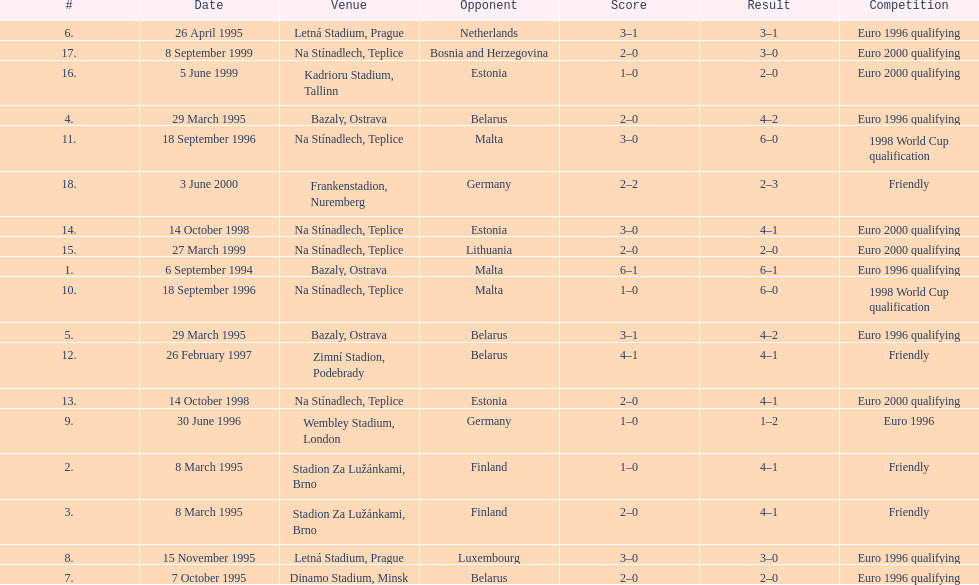How many total games took place in 1999? 3. 